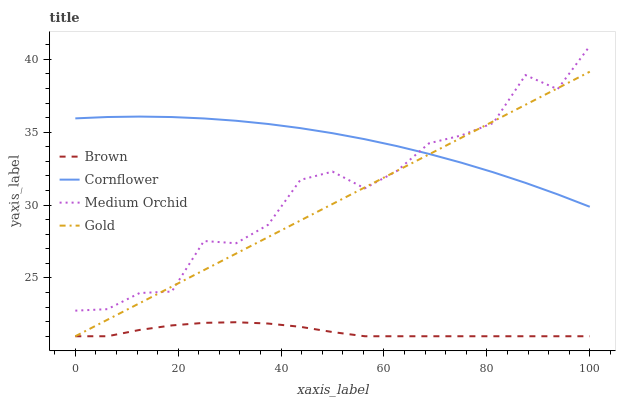Does Brown have the minimum area under the curve?
Answer yes or no. Yes. Does Cornflower have the maximum area under the curve?
Answer yes or no. Yes. Does Medium Orchid have the minimum area under the curve?
Answer yes or no. No. Does Medium Orchid have the maximum area under the curve?
Answer yes or no. No. Is Gold the smoothest?
Answer yes or no. Yes. Is Medium Orchid the roughest?
Answer yes or no. Yes. Is Medium Orchid the smoothest?
Answer yes or no. No. Is Gold the roughest?
Answer yes or no. No. Does Brown have the lowest value?
Answer yes or no. Yes. Does Medium Orchid have the lowest value?
Answer yes or no. No. Does Medium Orchid have the highest value?
Answer yes or no. Yes. Does Gold have the highest value?
Answer yes or no. No. Is Brown less than Cornflower?
Answer yes or no. Yes. Is Medium Orchid greater than Brown?
Answer yes or no. Yes. Does Medium Orchid intersect Cornflower?
Answer yes or no. Yes. Is Medium Orchid less than Cornflower?
Answer yes or no. No. Is Medium Orchid greater than Cornflower?
Answer yes or no. No. Does Brown intersect Cornflower?
Answer yes or no. No. 